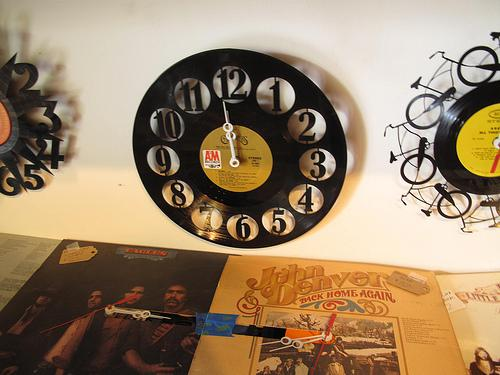Question: how many clocks are hanging on the wall?
Choices:
A. Two.
B. Three.
C. One.
D. Four.
Answer with the letter. Answer: B Question: what time does the middle clock say?
Choices:
A. 11:58.
B. 12:58.
C. 1:58.
D. 10:58.
Answer with the letter. Answer: A Question: what are the clocks made out of?
Choices:
A. CDs.
B. Cassette tapes.
C. Records.
D. Laserdiscs.
Answer with the letter. Answer: C Question: where are the clocks hanging?
Choices:
A. In the closet.
B. On the wall.
C. From the ceiling.
D. Outside.
Answer with the letter. Answer: B Question: what color are the second hands on the clocks not hanging?
Choices:
A. Black.
B. Green.
C. Red.
D. Blue.
Answer with the letter. Answer: C Question: how many numbers are on the clock hanging in the middle?
Choices:
A. Twelve.
B. Twenty-four.
C. Six.
D. One.
Answer with the letter. Answer: A 